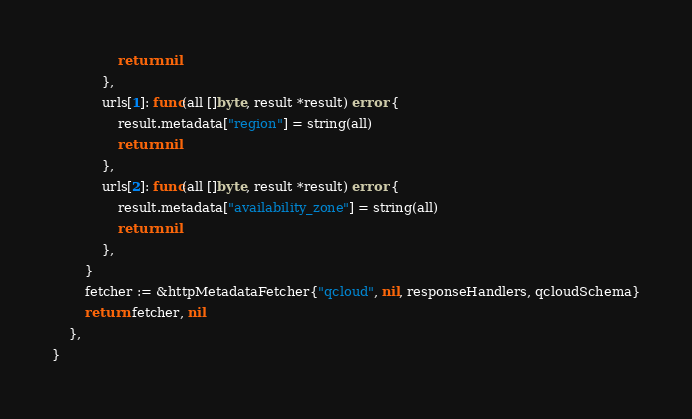<code> <loc_0><loc_0><loc_500><loc_500><_Go_>				return nil
			},
			urls[1]: func(all []byte, result *result) error {
				result.metadata["region"] = string(all)
				return nil
			},
			urls[2]: func(all []byte, result *result) error {
				result.metadata["availability_zone"] = string(all)
				return nil
			},
		}
		fetcher := &httpMetadataFetcher{"qcloud", nil, responseHandlers, qcloudSchema}
		return fetcher, nil
	},
}
</code> 